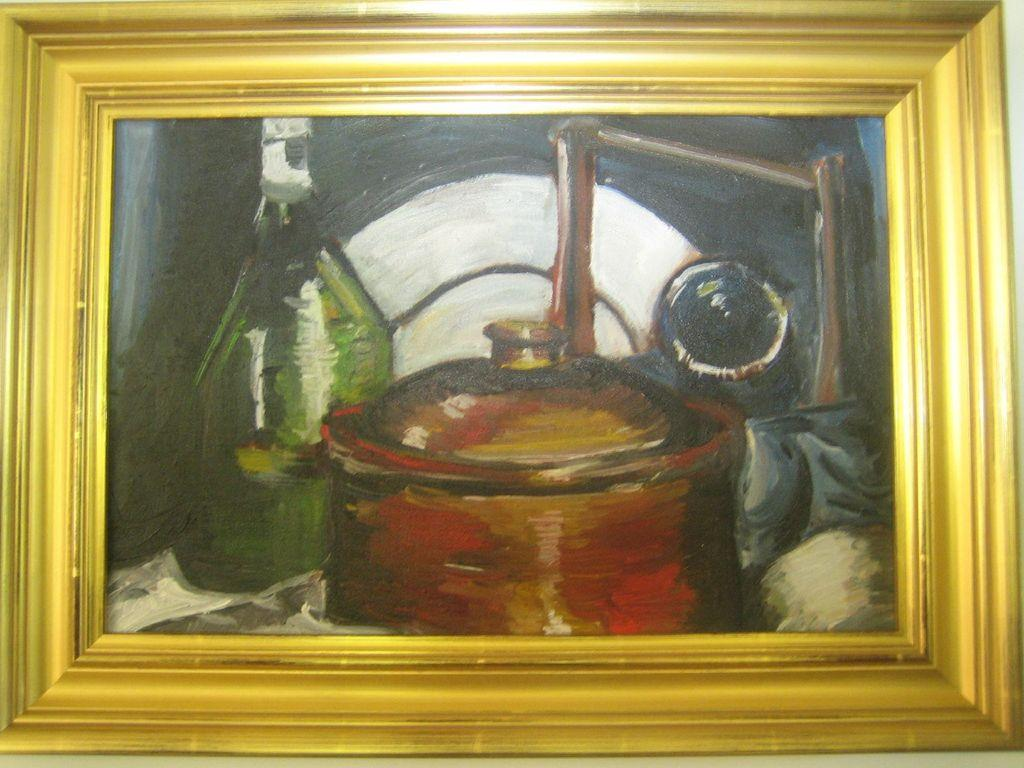What object is present in the image that typically holds a picture or artwork? There is a photo frame in the image. What is displayed within the photo frame? The photo frame contains a painting. How does the painting contribute to the reduction of pollution in the image? The painting does not contribute to the reduction of pollution in the image, as the image does not mention any pollution. 